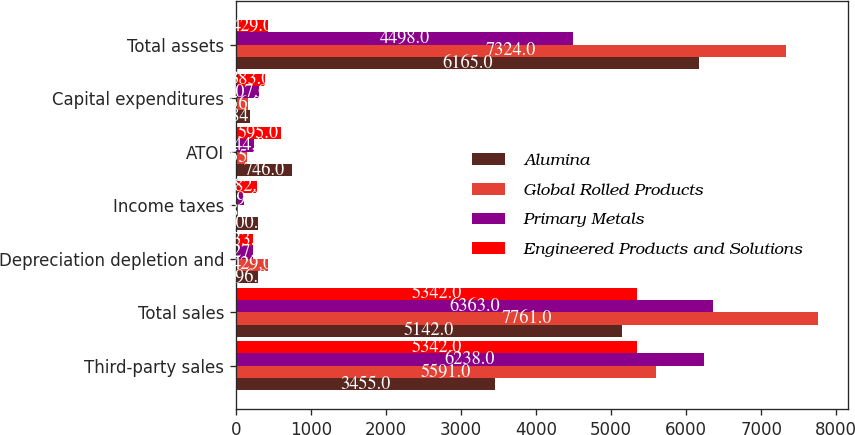Convert chart to OTSL. <chart><loc_0><loc_0><loc_500><loc_500><stacked_bar_chart><ecel><fcel>Third-party sales<fcel>Total sales<fcel>Depreciation depletion and<fcel>Income taxes<fcel>ATOI<fcel>Capital expenditures<fcel>Total assets<nl><fcel>Alumina<fcel>3455<fcel>5142<fcel>296<fcel>300<fcel>746<fcel>184<fcel>6165<nl><fcel>Global Rolled Products<fcel>5591<fcel>7761<fcel>429<fcel>28<fcel>155<fcel>156<fcel>7324<nl><fcel>Primary Metals<fcel>6238<fcel>6363<fcel>227<fcel>109<fcel>244<fcel>307<fcel>4498<nl><fcel>Engineered Products and Solutions<fcel>5342<fcel>5342<fcel>233<fcel>282<fcel>595<fcel>383<fcel>429<nl></chart> 